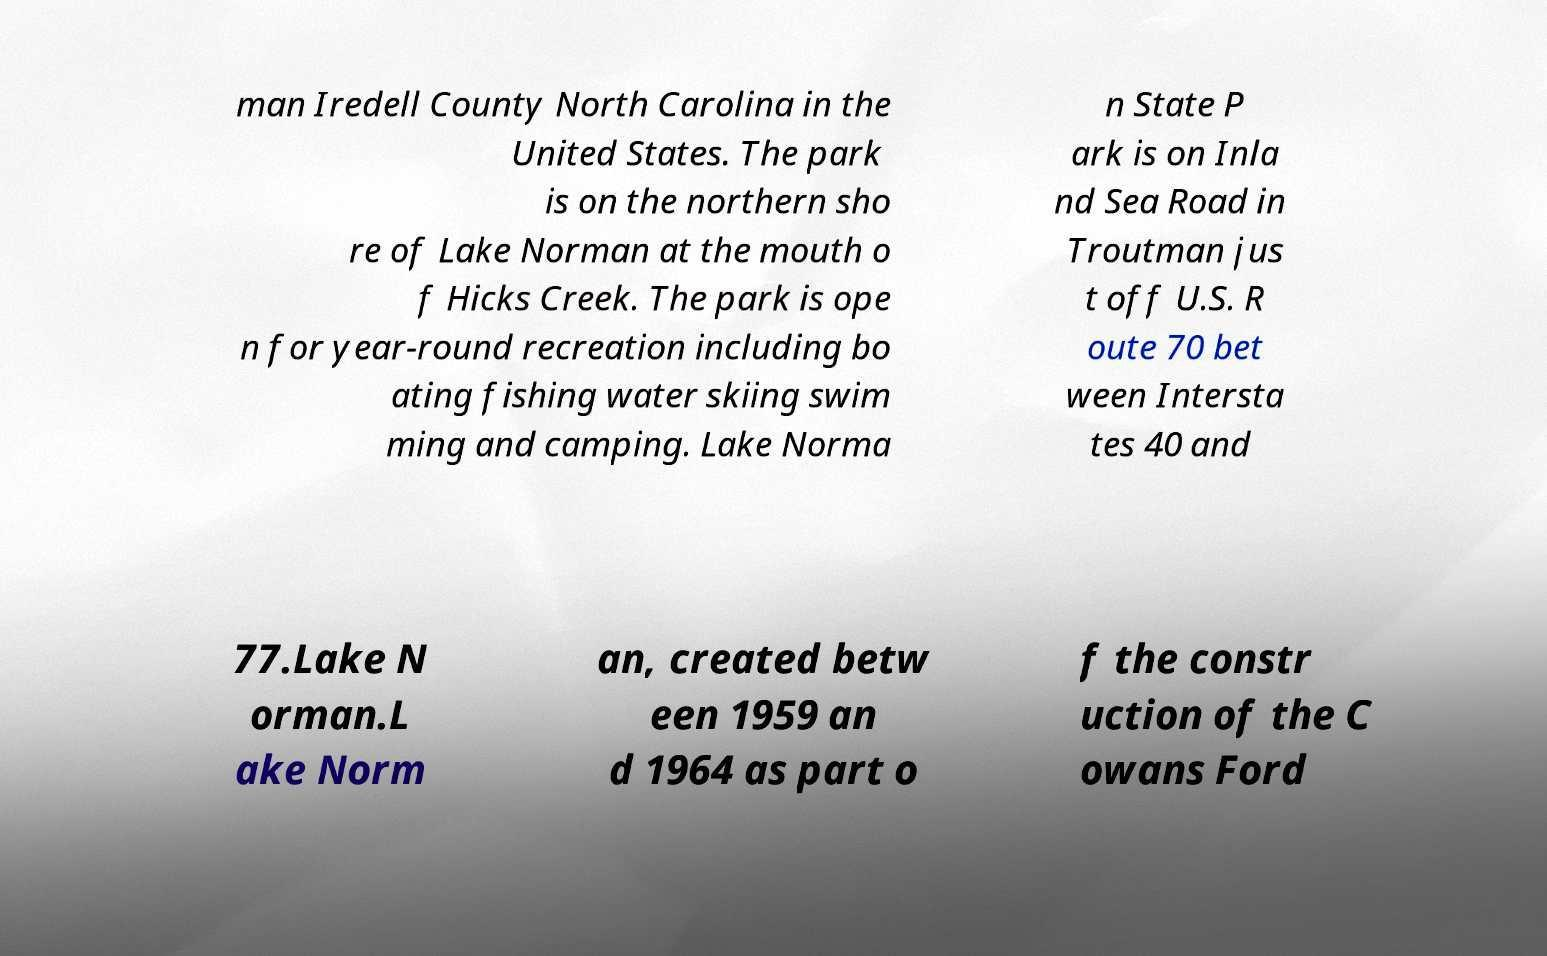Can you accurately transcribe the text from the provided image for me? man Iredell County North Carolina in the United States. The park is on the northern sho re of Lake Norman at the mouth o f Hicks Creek. The park is ope n for year-round recreation including bo ating fishing water skiing swim ming and camping. Lake Norma n State P ark is on Inla nd Sea Road in Troutman jus t off U.S. R oute 70 bet ween Intersta tes 40 and 77.Lake N orman.L ake Norm an, created betw een 1959 an d 1964 as part o f the constr uction of the C owans Ford 